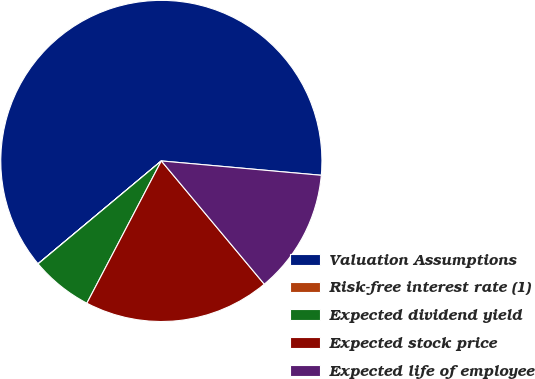<chart> <loc_0><loc_0><loc_500><loc_500><pie_chart><fcel>Valuation Assumptions<fcel>Risk-free interest rate (1)<fcel>Expected dividend yield<fcel>Expected stock price<fcel>Expected life of employee<nl><fcel>62.49%<fcel>0.01%<fcel>6.25%<fcel>18.75%<fcel>12.5%<nl></chart> 